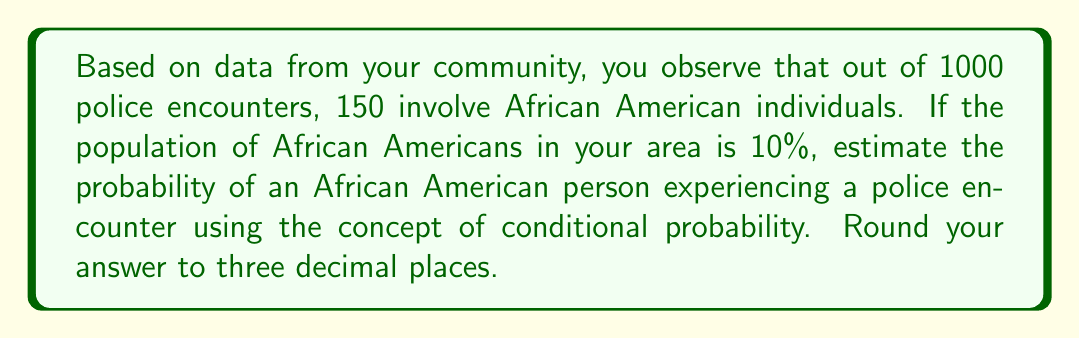Provide a solution to this math problem. Let's approach this step-by-step using conditional probability:

1) Define events:
   A: Being African American
   E: Experiencing a police encounter

2) Given information:
   P(A) = 0.10 (10% of the population is African American)
   P(E) = 1000/population (total encounters divided by total population)
   P(E|A) = 150/1000 = 0.15 (probability of encounter given person is African American)

3) We want to find P(E|A), which we already have. However, let's verify using Bayes' theorem:

   $$P(E|A) = \frac{P(A|E) \cdot P(E)}{P(A)}$$

4) We know P(A|E) = 150/1000 = 0.15
   We know P(A) = 0.10
   We need to calculate P(E):

   $$P(E) = \frac{1000}{\text{population}} = \frac{1000}{1000/0.10} = 0.10$$

5) Now we can apply Bayes' theorem:

   $$P(E|A) = \frac{0.15 \cdot 0.10}{0.10} = 0.15$$

6) Rounding to three decimal places: 0.150

This means an African American person in your community has a 15.0% probability of experiencing a police encounter.
Answer: 0.150 